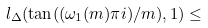Convert formula to latex. <formula><loc_0><loc_0><loc_500><loc_500>l _ { \Delta } ( \tan ( ( \omega _ { 1 } ( m ) \pi i ) / m ) , 1 ) \leq</formula> 